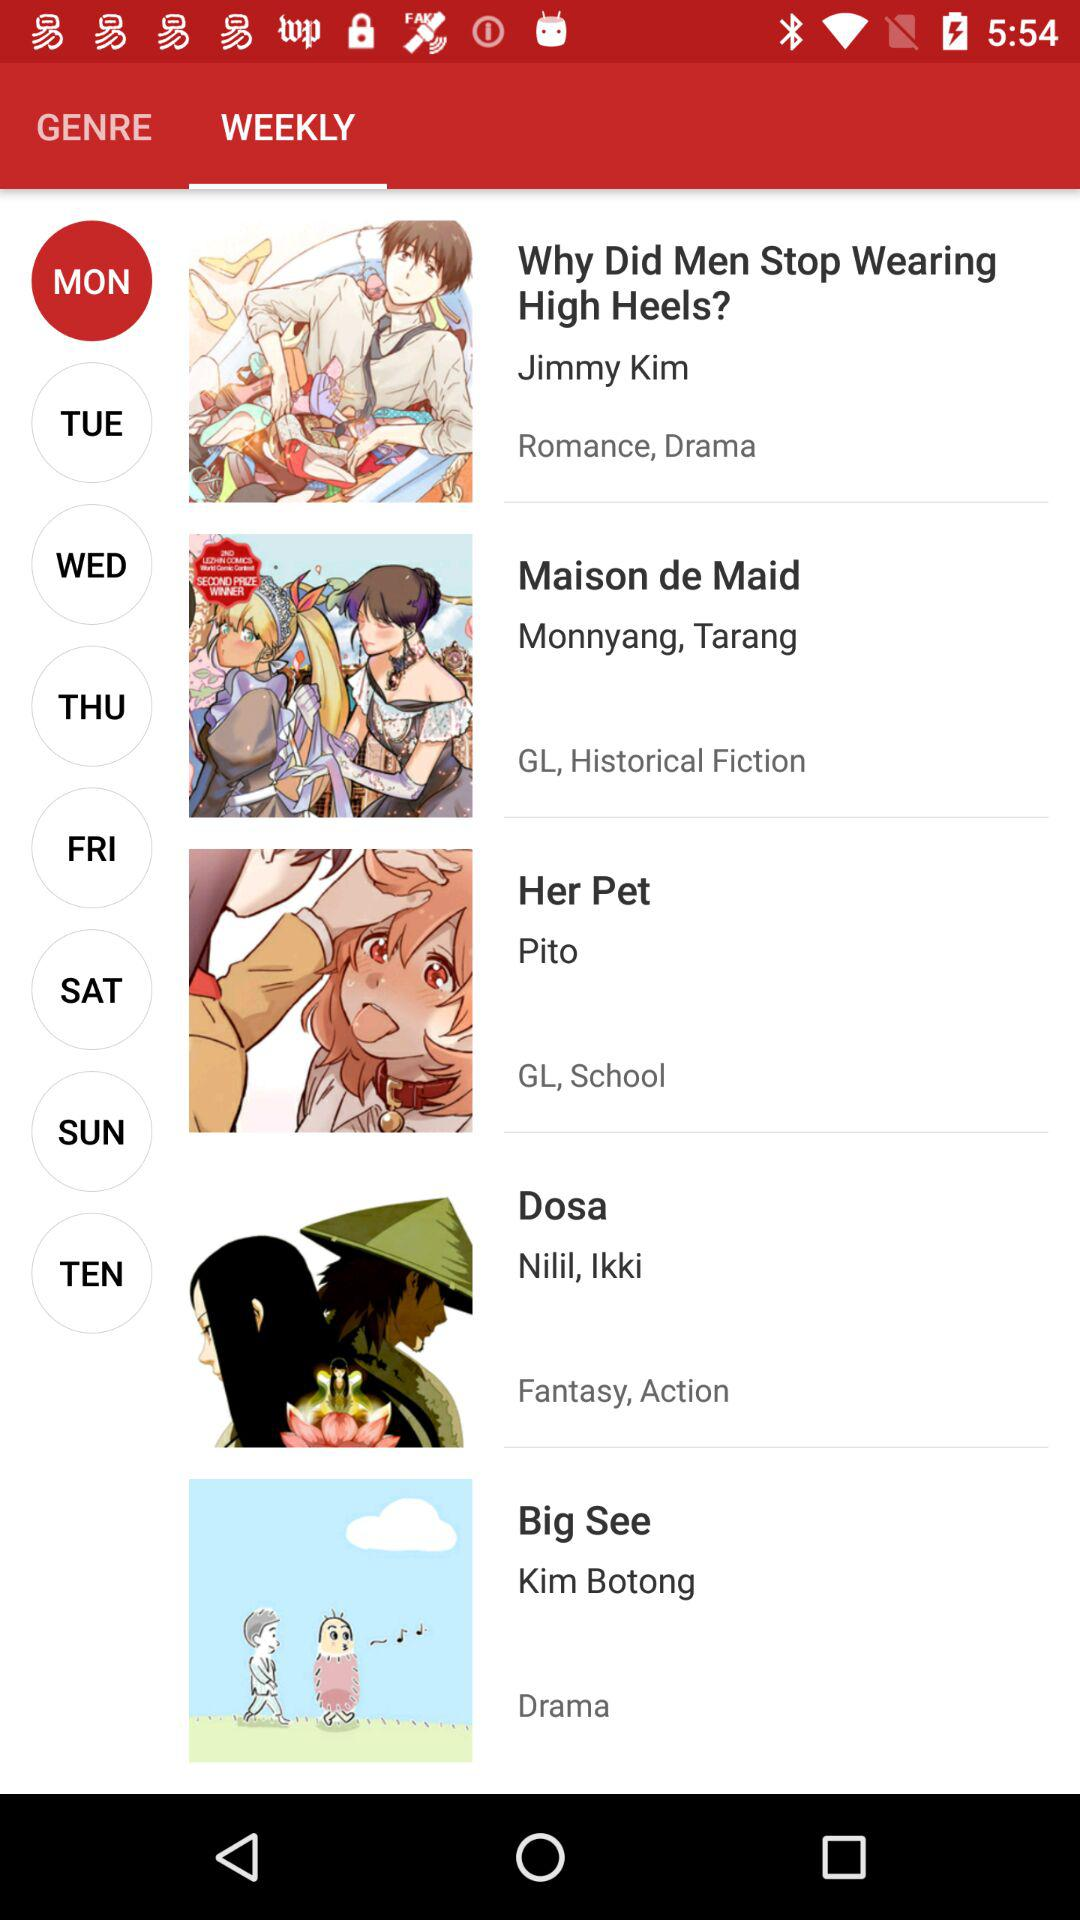Which tab is selected? The selected tab is "WEEKLY". 